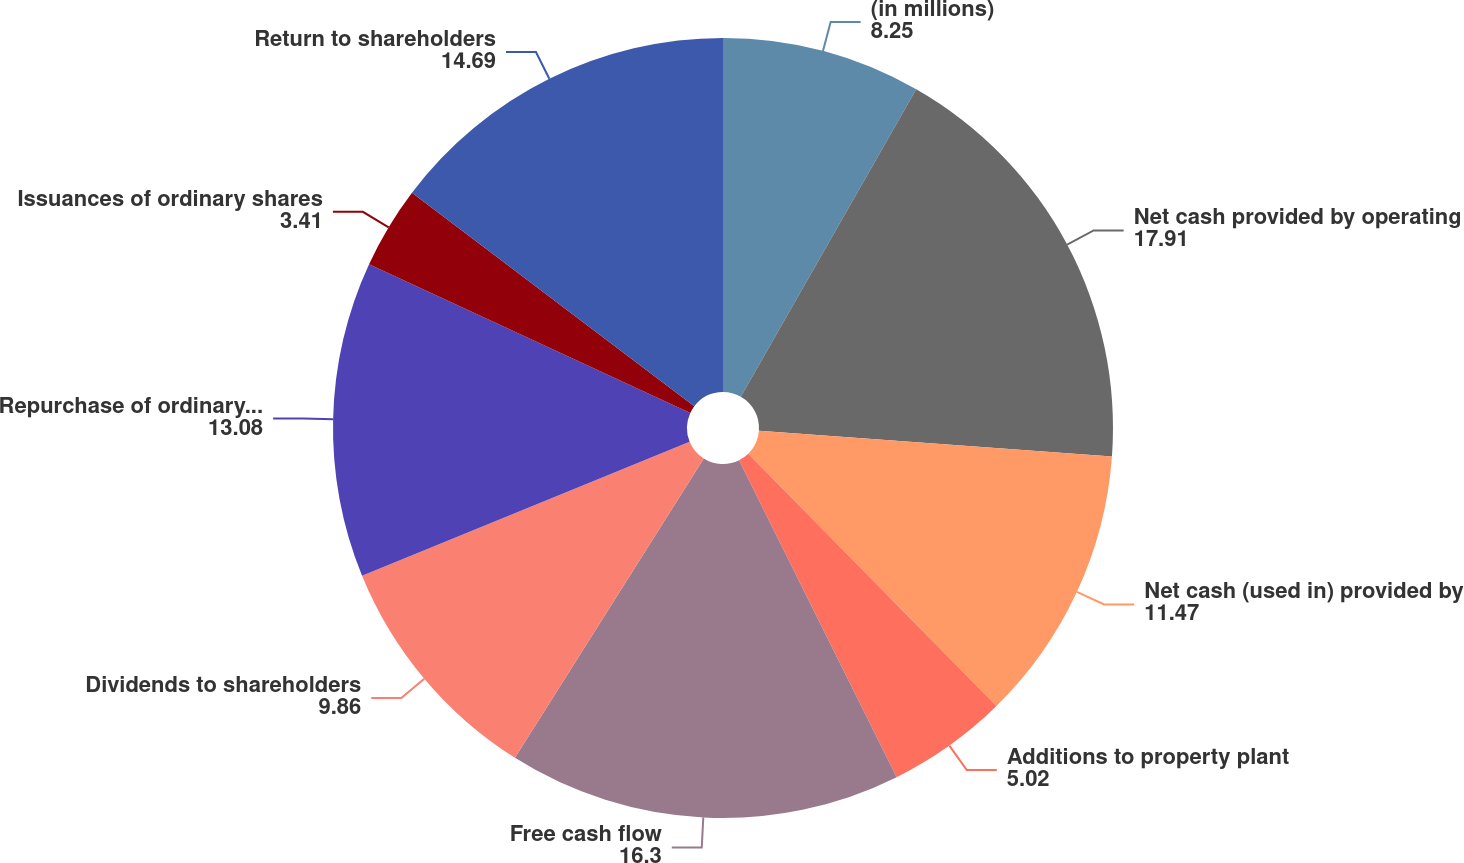<chart> <loc_0><loc_0><loc_500><loc_500><pie_chart><fcel>(in millions)<fcel>Net cash provided by operating<fcel>Net cash (used in) provided by<fcel>Additions to property plant<fcel>Free cash flow<fcel>Dividends to shareholders<fcel>Repurchase of ordinary shares<fcel>Issuances of ordinary shares<fcel>Return to shareholders<nl><fcel>8.25%<fcel>17.91%<fcel>11.47%<fcel>5.02%<fcel>16.3%<fcel>9.86%<fcel>13.08%<fcel>3.41%<fcel>14.69%<nl></chart> 